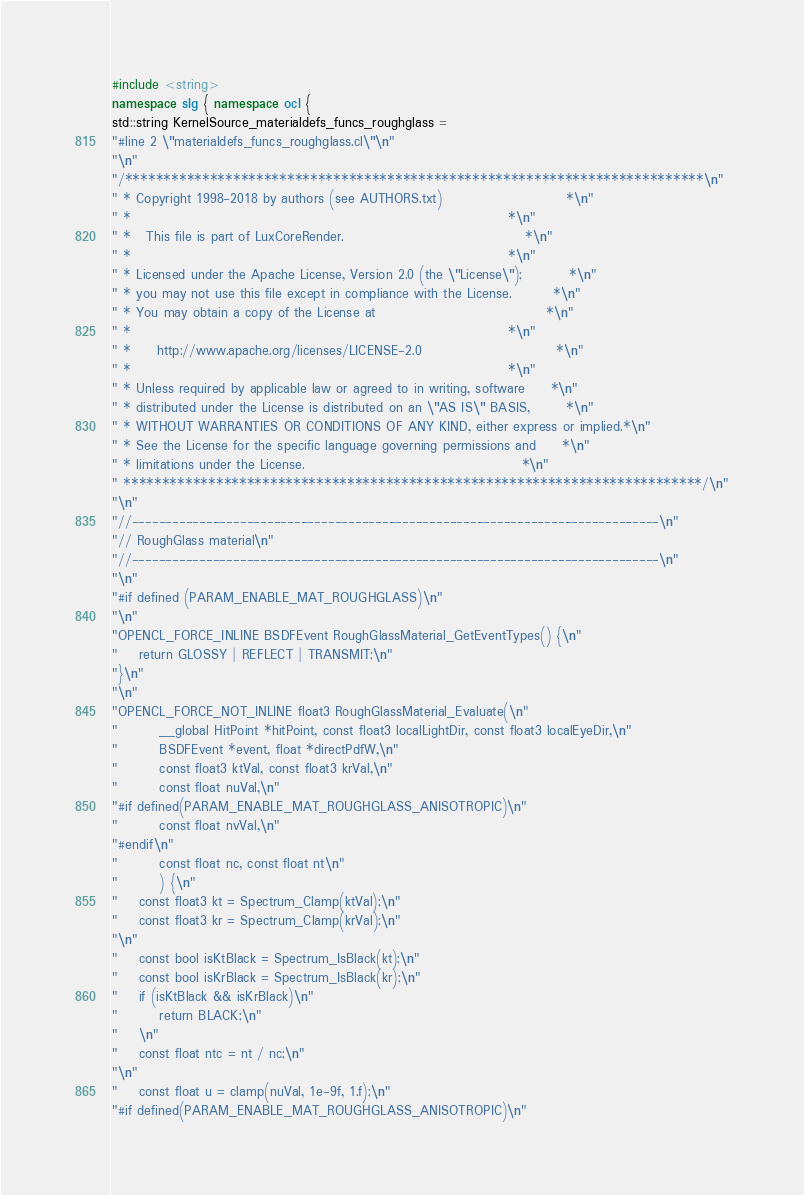<code> <loc_0><loc_0><loc_500><loc_500><_C++_>#include <string>
namespace slg { namespace ocl {
std::string KernelSource_materialdefs_funcs_roughglass = 
"#line 2 \"materialdefs_funcs_roughglass.cl\"\n"
"\n"
"/***************************************************************************\n"
" * Copyright 1998-2018 by authors (see AUTHORS.txt)                        *\n"
" *                                                                         *\n"
" *   This file is part of LuxCoreRender.                                   *\n"
" *                                                                         *\n"
" * Licensed under the Apache License, Version 2.0 (the \"License\");         *\n"
" * you may not use this file except in compliance with the License.        *\n"
" * You may obtain a copy of the License at                                 *\n"
" *                                                                         *\n"
" *     http://www.apache.org/licenses/LICENSE-2.0                          *\n"
" *                                                                         *\n"
" * Unless required by applicable law or agreed to in writing, software     *\n"
" * distributed under the License is distributed on an \"AS IS\" BASIS,       *\n"
" * WITHOUT WARRANTIES OR CONDITIONS OF ANY KIND, either express or implied.*\n"
" * See the License for the specific language governing permissions and     *\n"
" * limitations under the License.                                          *\n"
" ***************************************************************************/\n"
"\n"
"//------------------------------------------------------------------------------\n"
"// RoughGlass material\n"
"//------------------------------------------------------------------------------\n"
"\n"
"#if defined (PARAM_ENABLE_MAT_ROUGHGLASS)\n"
"\n"
"OPENCL_FORCE_INLINE BSDFEvent RoughGlassMaterial_GetEventTypes() {\n"
"	return GLOSSY | REFLECT | TRANSMIT;\n"
"}\n"
"\n"
"OPENCL_FORCE_NOT_INLINE float3 RoughGlassMaterial_Evaluate(\n"
"		__global HitPoint *hitPoint, const float3 localLightDir, const float3 localEyeDir,\n"
"		BSDFEvent *event, float *directPdfW,\n"
"		const float3 ktVal, const float3 krVal,\n"
"		const float nuVal,\n"
"#if defined(PARAM_ENABLE_MAT_ROUGHGLASS_ANISOTROPIC)\n"
"		const float nvVal,\n"
"#endif\n"
"		const float nc, const float nt\n"
"		) {\n"
"	const float3 kt = Spectrum_Clamp(ktVal);\n"
"	const float3 kr = Spectrum_Clamp(krVal);\n"
"\n"
"	const bool isKtBlack = Spectrum_IsBlack(kt);\n"
"	const bool isKrBlack = Spectrum_IsBlack(kr);\n"
"	if (isKtBlack && isKrBlack)\n"
"		return BLACK;\n"
"	\n"
"	const float ntc = nt / nc;\n"
"\n"
"	const float u = clamp(nuVal, 1e-9f, 1.f);\n"
"#if defined(PARAM_ENABLE_MAT_ROUGHGLASS_ANISOTROPIC)\n"</code> 